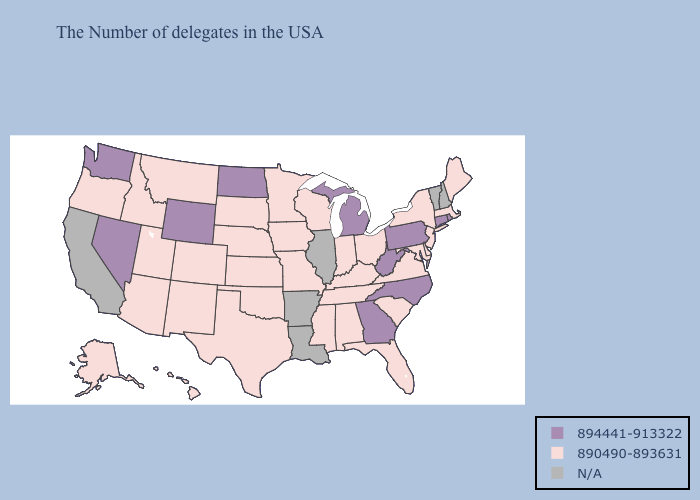Name the states that have a value in the range N/A?
Write a very short answer. New Hampshire, Vermont, Illinois, Louisiana, Arkansas, California. Name the states that have a value in the range N/A?
Answer briefly. New Hampshire, Vermont, Illinois, Louisiana, Arkansas, California. Among the states that border Idaho , which have the highest value?
Answer briefly. Wyoming, Nevada, Washington. What is the highest value in states that border Michigan?
Quick response, please. 890490-893631. Does the map have missing data?
Concise answer only. Yes. Which states have the lowest value in the South?
Short answer required. Delaware, Maryland, Virginia, South Carolina, Florida, Kentucky, Alabama, Tennessee, Mississippi, Oklahoma, Texas. Among the states that border Massachusetts , which have the highest value?
Answer briefly. Rhode Island, Connecticut. Which states have the lowest value in the USA?
Write a very short answer. Maine, Massachusetts, New York, New Jersey, Delaware, Maryland, Virginia, South Carolina, Ohio, Florida, Kentucky, Indiana, Alabama, Tennessee, Wisconsin, Mississippi, Missouri, Minnesota, Iowa, Kansas, Nebraska, Oklahoma, Texas, South Dakota, Colorado, New Mexico, Utah, Montana, Arizona, Idaho, Oregon, Alaska, Hawaii. What is the value of Mississippi?
Quick response, please. 890490-893631. What is the value of Mississippi?
Give a very brief answer. 890490-893631. Name the states that have a value in the range 890490-893631?
Keep it brief. Maine, Massachusetts, New York, New Jersey, Delaware, Maryland, Virginia, South Carolina, Ohio, Florida, Kentucky, Indiana, Alabama, Tennessee, Wisconsin, Mississippi, Missouri, Minnesota, Iowa, Kansas, Nebraska, Oklahoma, Texas, South Dakota, Colorado, New Mexico, Utah, Montana, Arizona, Idaho, Oregon, Alaska, Hawaii. 